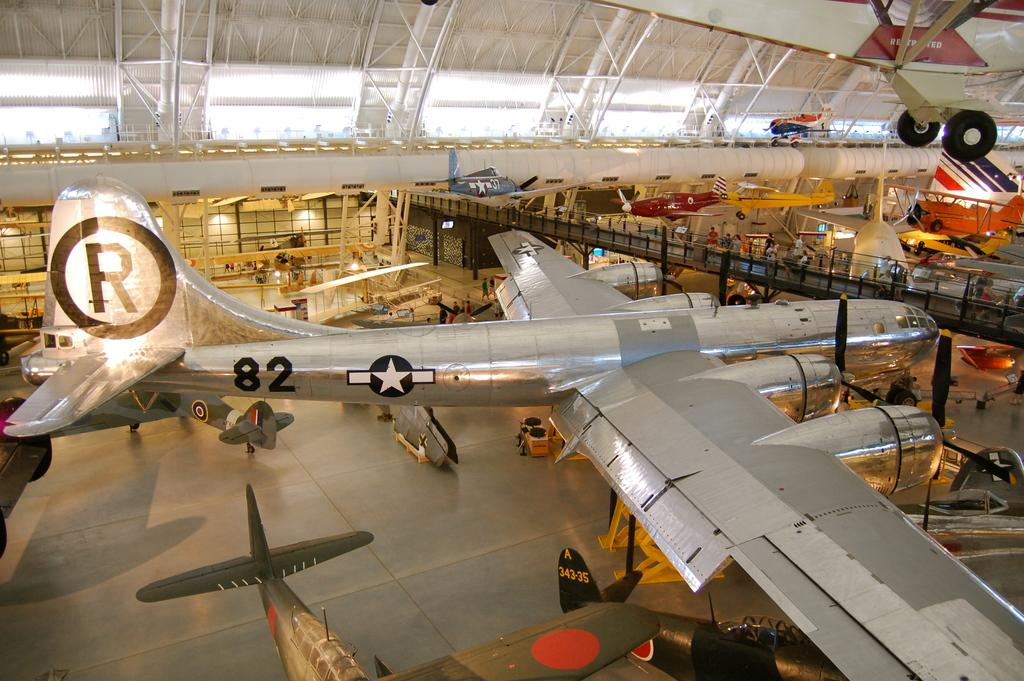<image>
Render a clear and concise summary of the photo. An airplane labelled "82" is on display in a museum. 